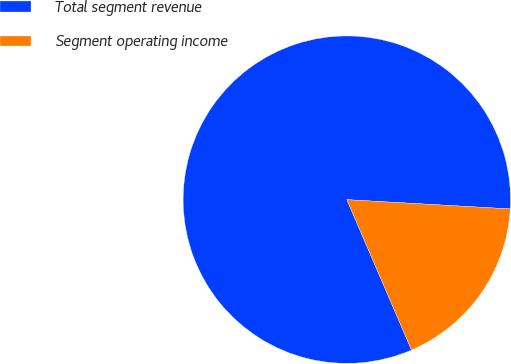Convert chart to OTSL. <chart><loc_0><loc_0><loc_500><loc_500><pie_chart><fcel>Total segment revenue<fcel>Segment operating income<nl><fcel>82.37%<fcel>17.63%<nl></chart> 